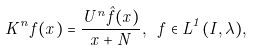<formula> <loc_0><loc_0><loc_500><loc_500>K ^ { n } f ( x ) = \frac { U ^ { n } \hat { f } ( x ) } { x + N } , \ f \in L ^ { 1 } ( I , \lambda ) ,</formula> 